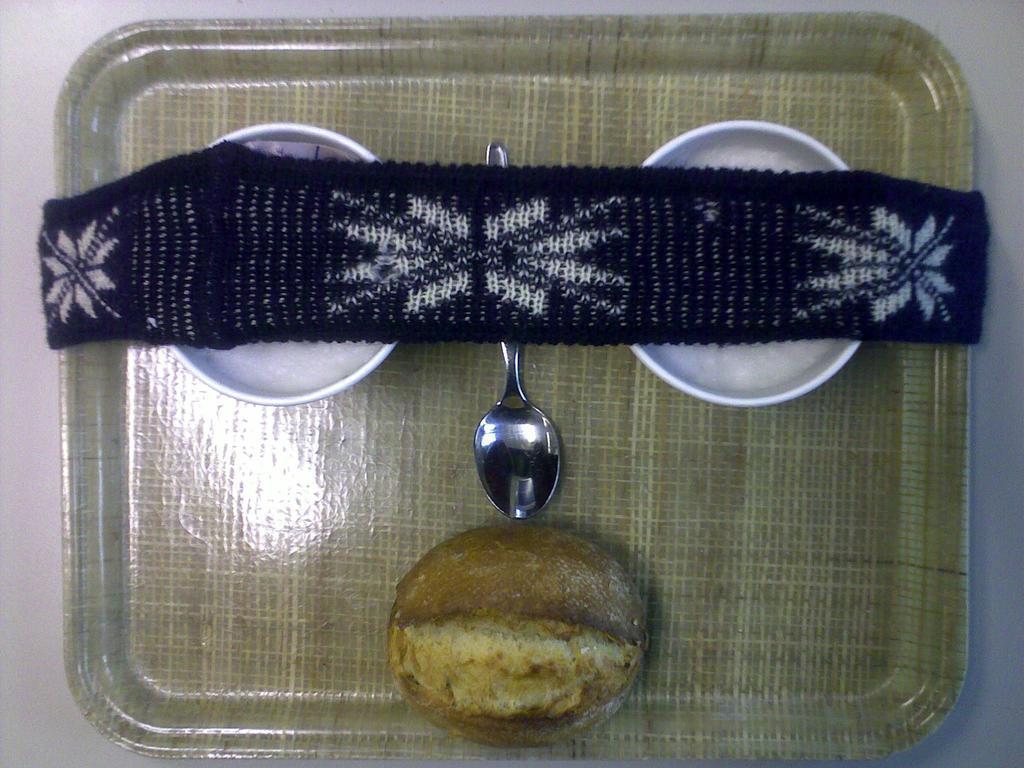How would you summarize this image in a sentence or two? In this picture we can see a food item, a spoon and a cloth on the bowls are visible on a tray. Background is white in color. 